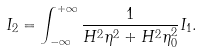<formula> <loc_0><loc_0><loc_500><loc_500>I _ { 2 } = \int ^ { + \infty } _ { - \infty } \frac { 1 } { H ^ { 2 } \eta ^ { 2 } + H ^ { 2 } \eta _ { 0 } ^ { 2 } } I _ { 1 } .</formula> 